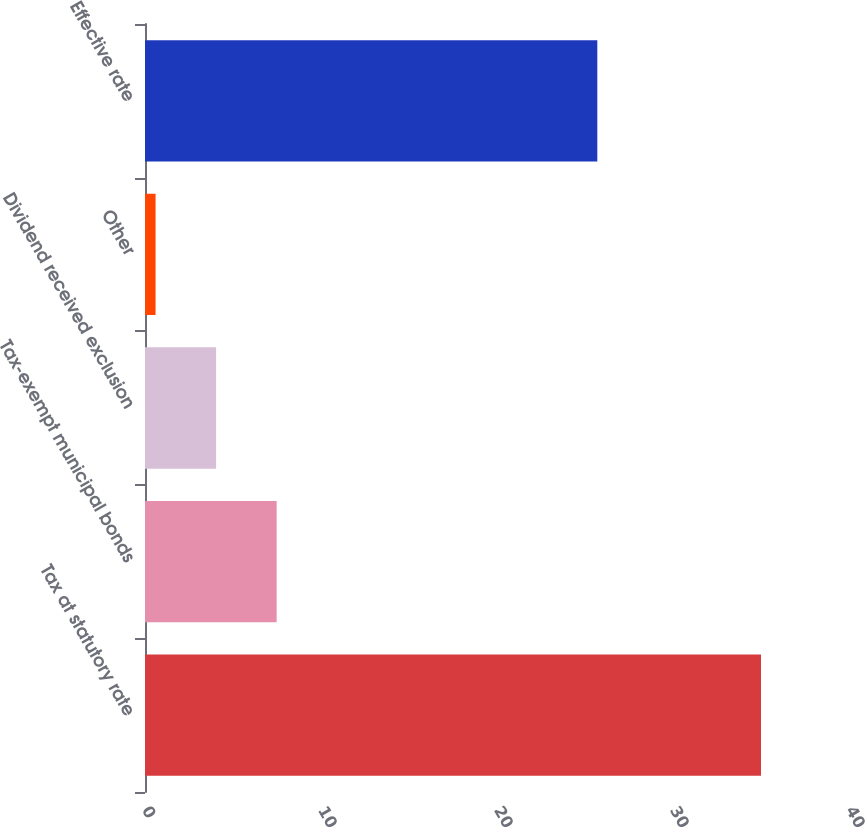<chart> <loc_0><loc_0><loc_500><loc_500><bar_chart><fcel>Tax at statutory rate<fcel>Tax-exempt municipal bonds<fcel>Dividend received exclusion<fcel>Other<fcel>Effective rate<nl><fcel>35<fcel>7.48<fcel>4.04<fcel>0.6<fcel>25.7<nl></chart> 